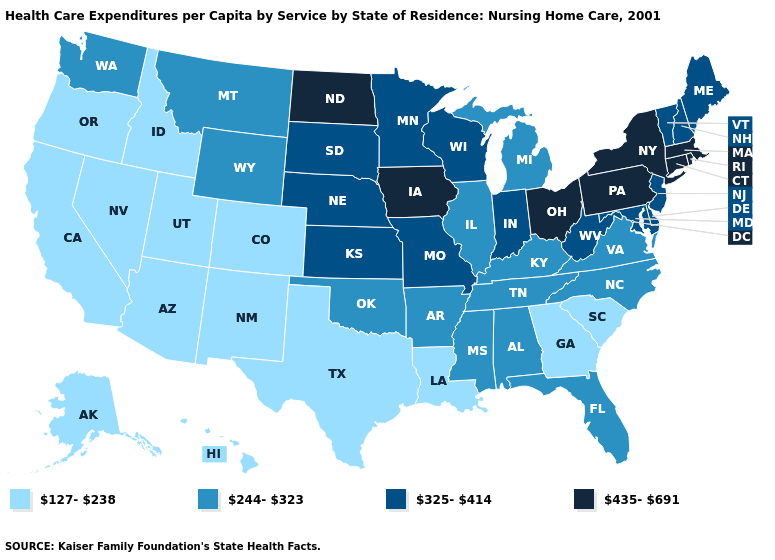Does Iowa have the same value as Rhode Island?
Short answer required. Yes. Name the states that have a value in the range 325-414?
Short answer required. Delaware, Indiana, Kansas, Maine, Maryland, Minnesota, Missouri, Nebraska, New Hampshire, New Jersey, South Dakota, Vermont, West Virginia, Wisconsin. What is the value of Texas?
Short answer required. 127-238. What is the lowest value in states that border Massachusetts?
Answer briefly. 325-414. Among the states that border West Virginia , does Virginia have the highest value?
Concise answer only. No. Does North Dakota have the highest value in the USA?
Answer briefly. Yes. Does the first symbol in the legend represent the smallest category?
Write a very short answer. Yes. What is the value of West Virginia?
Concise answer only. 325-414. Which states hav the highest value in the MidWest?
Concise answer only. Iowa, North Dakota, Ohio. What is the value of Maryland?
Be succinct. 325-414. Name the states that have a value in the range 127-238?
Write a very short answer. Alaska, Arizona, California, Colorado, Georgia, Hawaii, Idaho, Louisiana, Nevada, New Mexico, Oregon, South Carolina, Texas, Utah. Name the states that have a value in the range 435-691?
Concise answer only. Connecticut, Iowa, Massachusetts, New York, North Dakota, Ohio, Pennsylvania, Rhode Island. What is the value of Washington?
Quick response, please. 244-323. Does Alaska have the same value as Pennsylvania?
Keep it brief. No. 